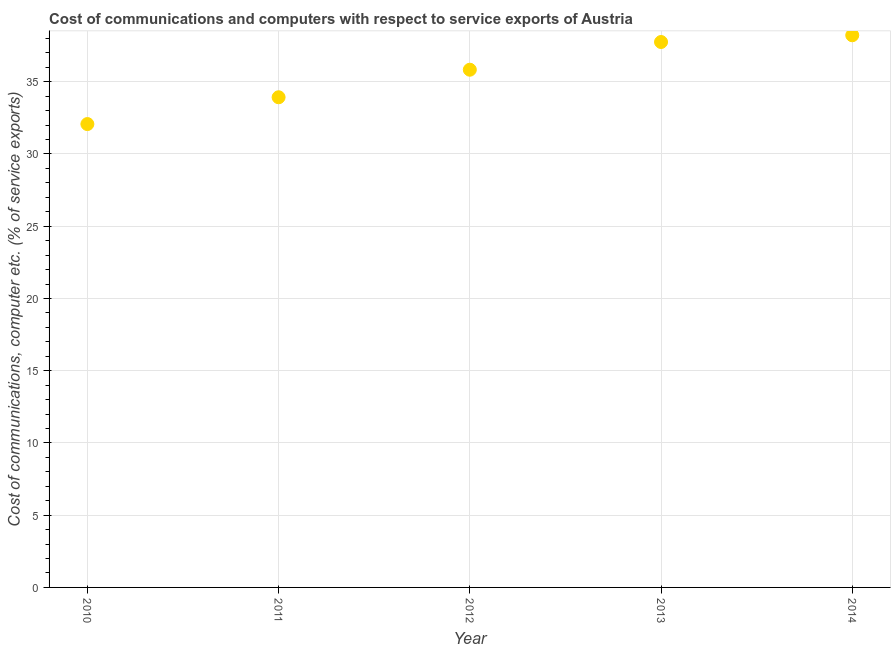What is the cost of communications and computer in 2010?
Keep it short and to the point. 32.07. Across all years, what is the maximum cost of communications and computer?
Keep it short and to the point. 38.22. Across all years, what is the minimum cost of communications and computer?
Offer a very short reply. 32.07. In which year was the cost of communications and computer minimum?
Ensure brevity in your answer.  2010. What is the sum of the cost of communications and computer?
Keep it short and to the point. 177.8. What is the difference between the cost of communications and computer in 2010 and 2014?
Your answer should be very brief. -6.15. What is the average cost of communications and computer per year?
Give a very brief answer. 35.56. What is the median cost of communications and computer?
Make the answer very short. 35.83. In how many years, is the cost of communications and computer greater than 20 %?
Provide a succinct answer. 5. What is the ratio of the cost of communications and computer in 2012 to that in 2014?
Keep it short and to the point. 0.94. What is the difference between the highest and the second highest cost of communications and computer?
Keep it short and to the point. 0.47. Is the sum of the cost of communications and computer in 2010 and 2014 greater than the maximum cost of communications and computer across all years?
Your answer should be very brief. Yes. What is the difference between the highest and the lowest cost of communications and computer?
Make the answer very short. 6.15. How many dotlines are there?
Your answer should be compact. 1. Are the values on the major ticks of Y-axis written in scientific E-notation?
Provide a succinct answer. No. Does the graph contain grids?
Provide a short and direct response. Yes. What is the title of the graph?
Make the answer very short. Cost of communications and computers with respect to service exports of Austria. What is the label or title of the Y-axis?
Your response must be concise. Cost of communications, computer etc. (% of service exports). What is the Cost of communications, computer etc. (% of service exports) in 2010?
Your answer should be compact. 32.07. What is the Cost of communications, computer etc. (% of service exports) in 2011?
Your answer should be very brief. 33.93. What is the Cost of communications, computer etc. (% of service exports) in 2012?
Give a very brief answer. 35.83. What is the Cost of communications, computer etc. (% of service exports) in 2013?
Keep it short and to the point. 37.75. What is the Cost of communications, computer etc. (% of service exports) in 2014?
Provide a short and direct response. 38.22. What is the difference between the Cost of communications, computer etc. (% of service exports) in 2010 and 2011?
Offer a very short reply. -1.86. What is the difference between the Cost of communications, computer etc. (% of service exports) in 2010 and 2012?
Offer a terse response. -3.76. What is the difference between the Cost of communications, computer etc. (% of service exports) in 2010 and 2013?
Offer a very short reply. -5.68. What is the difference between the Cost of communications, computer etc. (% of service exports) in 2010 and 2014?
Keep it short and to the point. -6.15. What is the difference between the Cost of communications, computer etc. (% of service exports) in 2011 and 2012?
Give a very brief answer. -1.91. What is the difference between the Cost of communications, computer etc. (% of service exports) in 2011 and 2013?
Offer a terse response. -3.82. What is the difference between the Cost of communications, computer etc. (% of service exports) in 2011 and 2014?
Provide a short and direct response. -4.29. What is the difference between the Cost of communications, computer etc. (% of service exports) in 2012 and 2013?
Keep it short and to the point. -1.92. What is the difference between the Cost of communications, computer etc. (% of service exports) in 2012 and 2014?
Your answer should be very brief. -2.38. What is the difference between the Cost of communications, computer etc. (% of service exports) in 2013 and 2014?
Make the answer very short. -0.47. What is the ratio of the Cost of communications, computer etc. (% of service exports) in 2010 to that in 2011?
Your answer should be very brief. 0.94. What is the ratio of the Cost of communications, computer etc. (% of service exports) in 2010 to that in 2012?
Your answer should be very brief. 0.9. What is the ratio of the Cost of communications, computer etc. (% of service exports) in 2010 to that in 2013?
Keep it short and to the point. 0.85. What is the ratio of the Cost of communications, computer etc. (% of service exports) in 2010 to that in 2014?
Make the answer very short. 0.84. What is the ratio of the Cost of communications, computer etc. (% of service exports) in 2011 to that in 2012?
Your response must be concise. 0.95. What is the ratio of the Cost of communications, computer etc. (% of service exports) in 2011 to that in 2013?
Your response must be concise. 0.9. What is the ratio of the Cost of communications, computer etc. (% of service exports) in 2011 to that in 2014?
Offer a terse response. 0.89. What is the ratio of the Cost of communications, computer etc. (% of service exports) in 2012 to that in 2013?
Your response must be concise. 0.95. What is the ratio of the Cost of communications, computer etc. (% of service exports) in 2012 to that in 2014?
Provide a succinct answer. 0.94. 